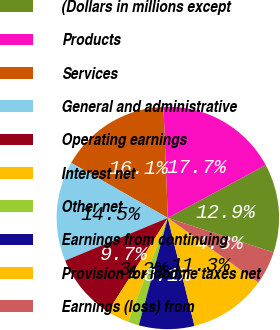Convert chart to OTSL. <chart><loc_0><loc_0><loc_500><loc_500><pie_chart><fcel>(Dollars in millions except<fcel>Products<fcel>Services<fcel>General and administrative<fcel>Operating earnings<fcel>Interest net<fcel>Other net<fcel>Earnings from continuing<fcel>Provision for income taxes net<fcel>Earnings (loss) from<nl><fcel>12.9%<fcel>17.74%<fcel>16.13%<fcel>14.52%<fcel>9.68%<fcel>3.23%<fcel>1.61%<fcel>8.06%<fcel>11.29%<fcel>4.84%<nl></chart> 